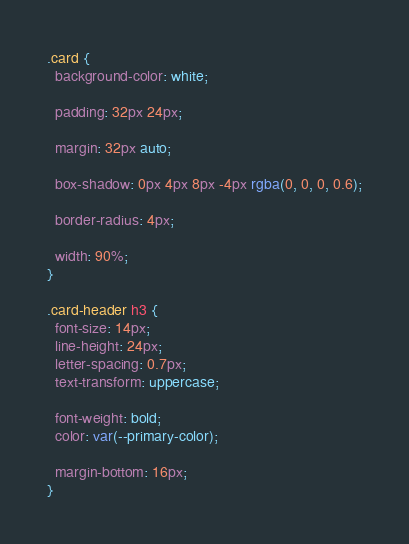Convert code to text. <code><loc_0><loc_0><loc_500><loc_500><_CSS_>.card {
  background-color: white;

  padding: 32px 24px;

  margin: 32px auto;

  box-shadow: 0px 4px 8px -4px rgba(0, 0, 0, 0.6);

  border-radius: 4px;

  width: 90%;
}

.card-header h3 {
  font-size: 14px;
  line-height: 24px;
  letter-spacing: 0.7px;
  text-transform: uppercase;

  font-weight: bold;
  color: var(--primary-color);

  margin-bottom: 16px;
}
</code> 